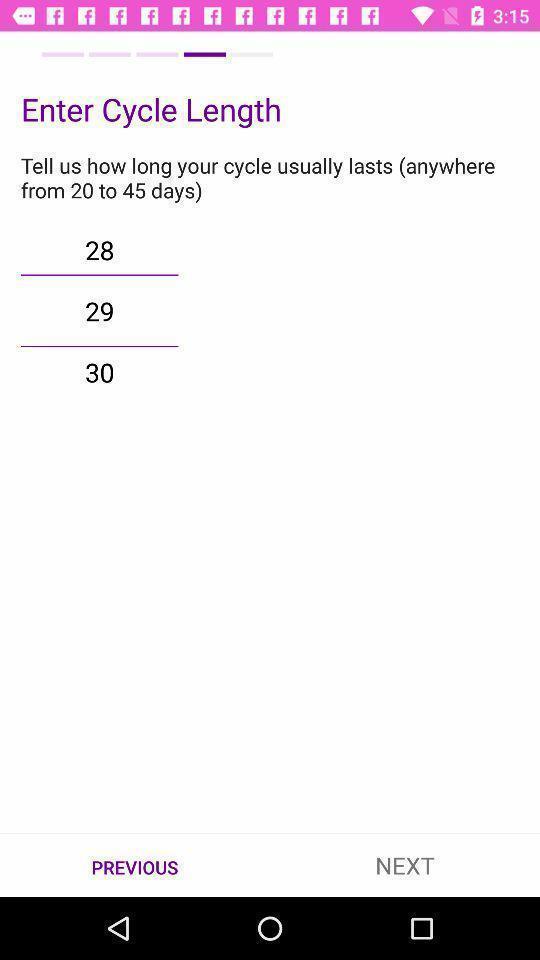Describe the key features of this screenshot. Screen shows enter cycle length details in a health application. 